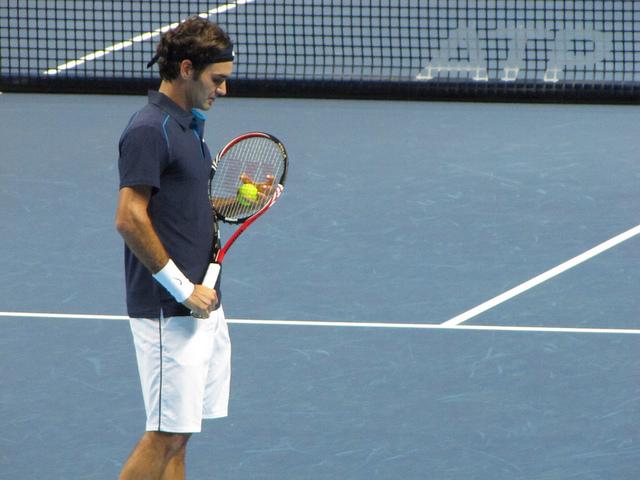What color is the ball?
Short answer required. Yellow. What is around the man's head?
Write a very short answer. Headband. What does the man have in his hands?
Short answer required. Racquet. 